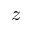<formula> <loc_0><loc_0><loc_500><loc_500>z</formula> 